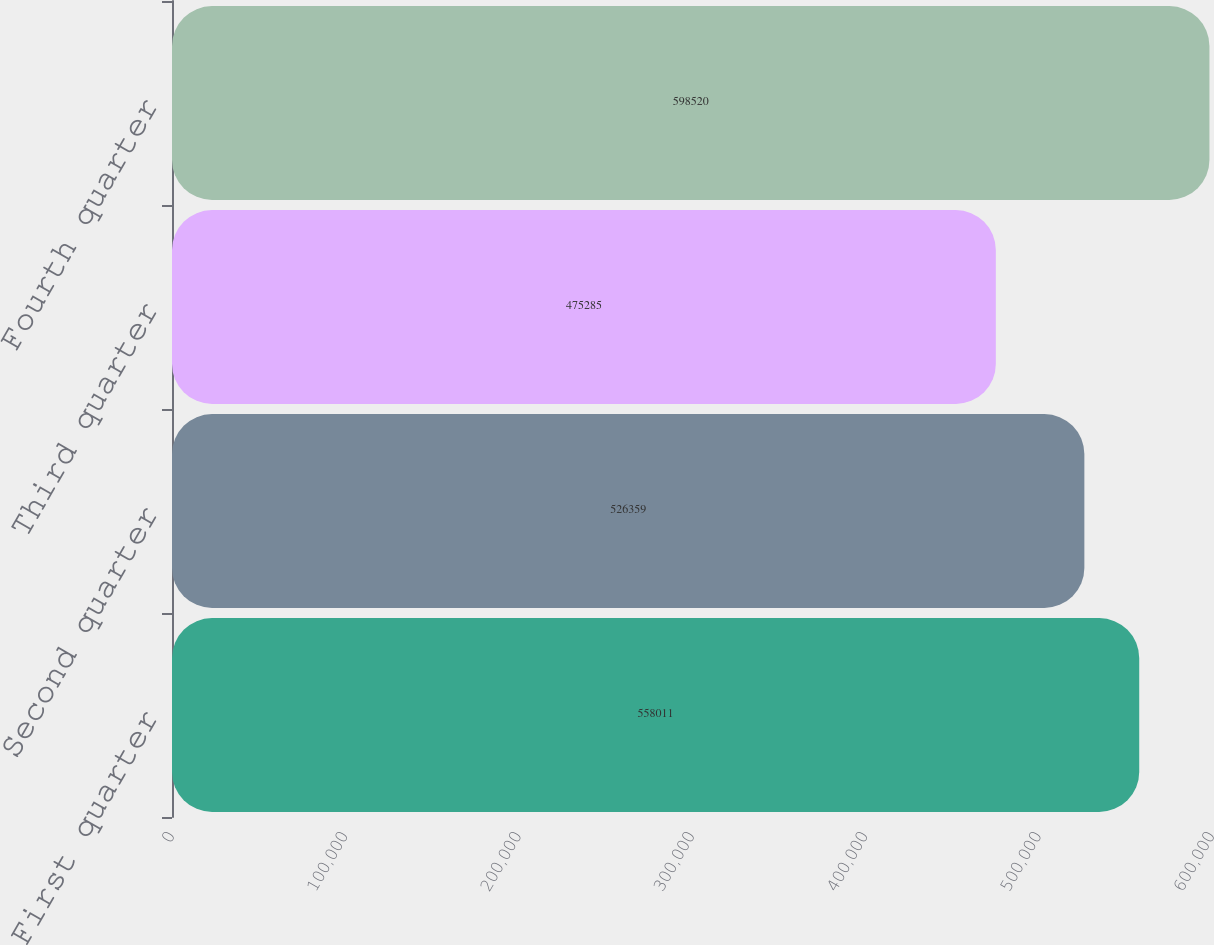Convert chart to OTSL. <chart><loc_0><loc_0><loc_500><loc_500><bar_chart><fcel>First quarter<fcel>Second quarter<fcel>Third quarter<fcel>Fourth quarter<nl><fcel>558011<fcel>526359<fcel>475285<fcel>598520<nl></chart> 